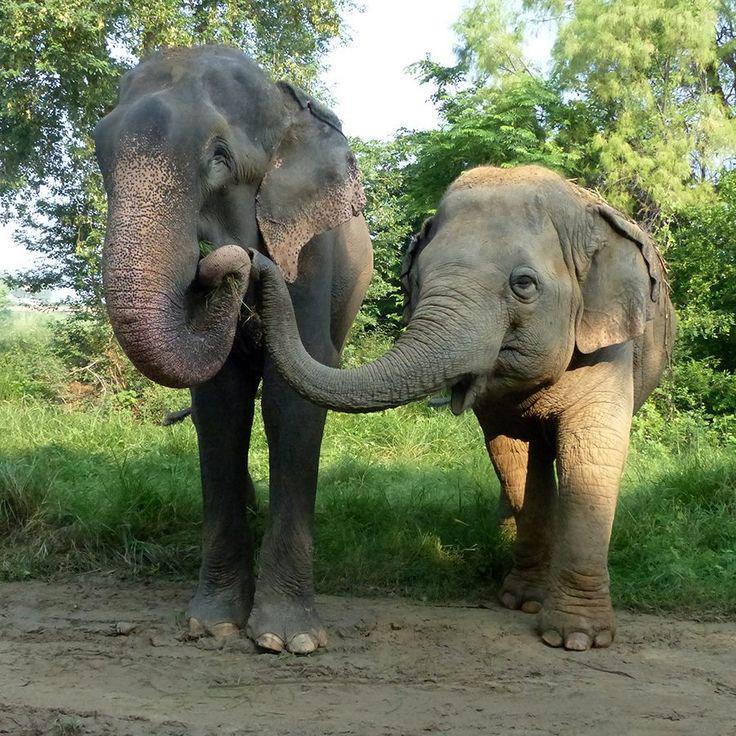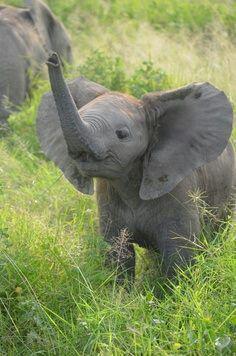The first image is the image on the left, the second image is the image on the right. Considering the images on both sides, is "A small white bird with a long beak appears in one image standing near at least one elephant." valid? Answer yes or no. No. The first image is the image on the left, the second image is the image on the right. Considering the images on both sides, is "An image shows at least one elephant with feet in the water." valid? Answer yes or no. No. 